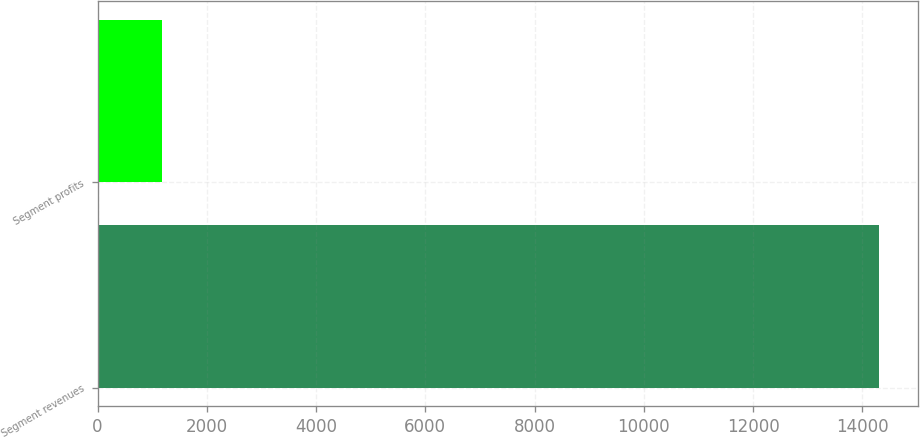Convert chart. <chart><loc_0><loc_0><loc_500><loc_500><bar_chart><fcel>Segment revenues<fcel>Segment profits<nl><fcel>14300<fcel>1182<nl></chart> 